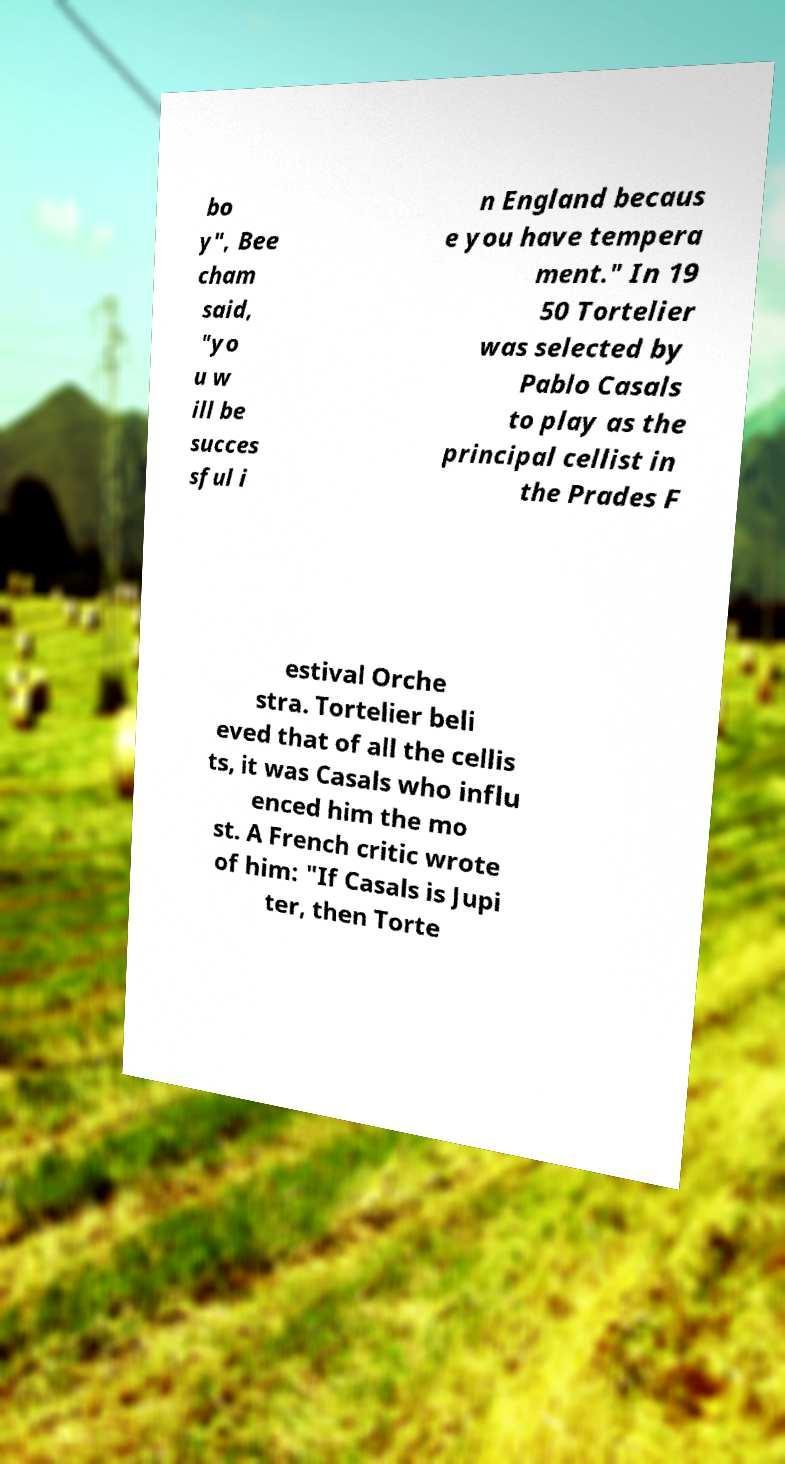Could you assist in decoding the text presented in this image and type it out clearly? bo y", Bee cham said, "yo u w ill be succes sful i n England becaus e you have tempera ment." In 19 50 Tortelier was selected by Pablo Casals to play as the principal cellist in the Prades F estival Orche stra. Tortelier beli eved that of all the cellis ts, it was Casals who influ enced him the mo st. A French critic wrote of him: "If Casals is Jupi ter, then Torte 